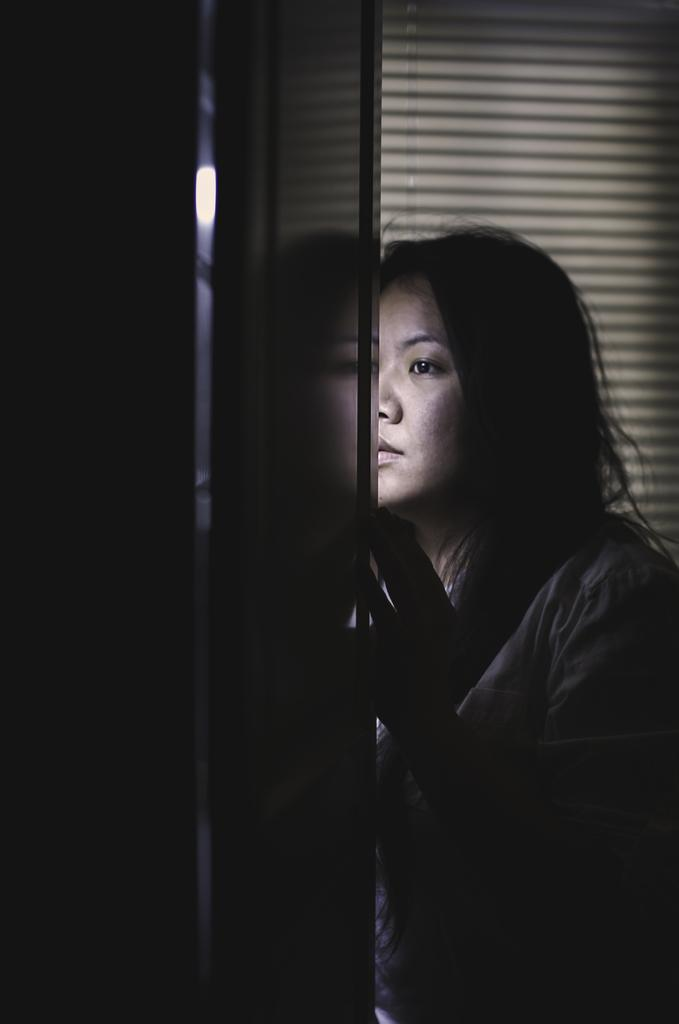Where was the image taken? The image was taken indoors. What can be seen in the background of the image? There is a window blind in the background of the image. What is on the left side of the image? There is a wall on the left side of the image. Who is present in the image? There is a woman on the right side of the image. What type of ship can be seen sailing in the background of the image? There is no ship present in the image; it was taken indoors with a window blind in the background. 